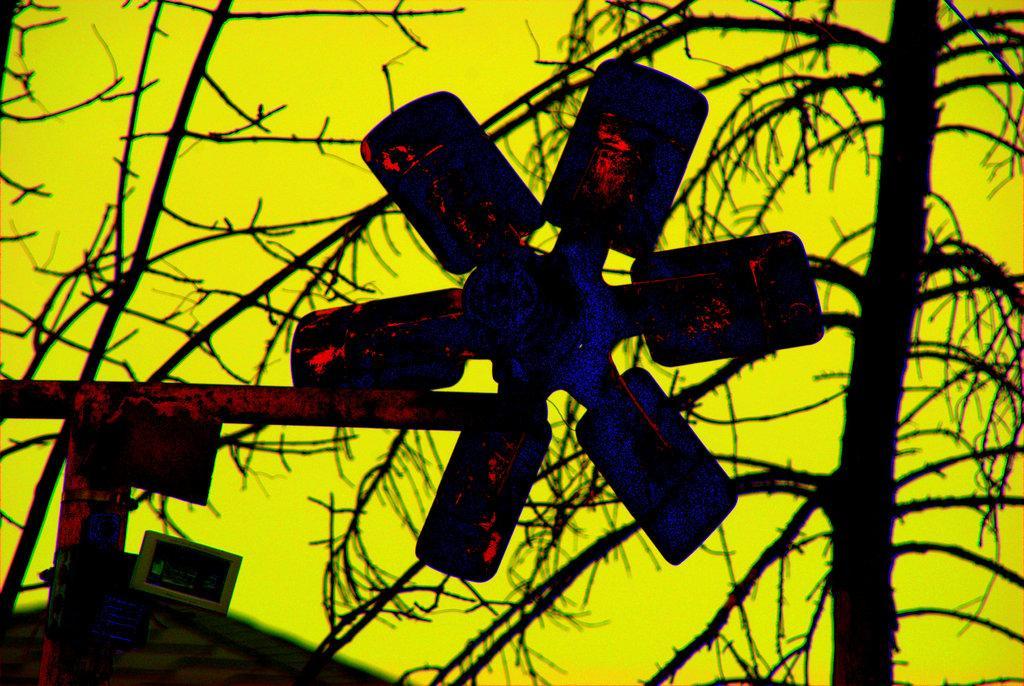How would you summarize this image in a sentence or two? in this image there is a fan in middle of this image and there is a dry tree on the right side of this image. There is a sky in the background which is in yellow color. 